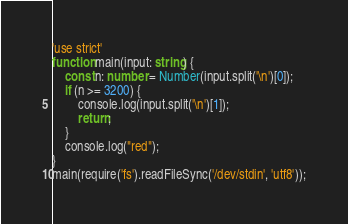Convert code to text. <code><loc_0><loc_0><loc_500><loc_500><_TypeScript_>'use strict'
function main(input: string) {
    const n: number = Number(input.split('\n')[0]);
    if (n >= 3200) {
        console.log(input.split('\n')[1]);
        return;
    }
    console.log("red");
}
main(require('fs').readFileSync('/dev/stdin', 'utf8'));</code> 